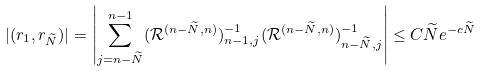Convert formula to latex. <formula><loc_0><loc_0><loc_500><loc_500>| ( r _ { 1 } , r _ { \widetilde { N } } ) | = \left | \sum _ { j = n - \widetilde { N } } ^ { n - 1 } ( \mathcal { R } ^ { ( n - \widetilde { N } , n ) } ) ^ { - 1 } _ { n - 1 , j } ( \mathcal { R } ^ { ( n - \widetilde { N } , n ) } ) ^ { - 1 } _ { n - \widetilde { N } , j } \right | \leq C \widetilde { N } e ^ { - c \widetilde { N } }</formula> 